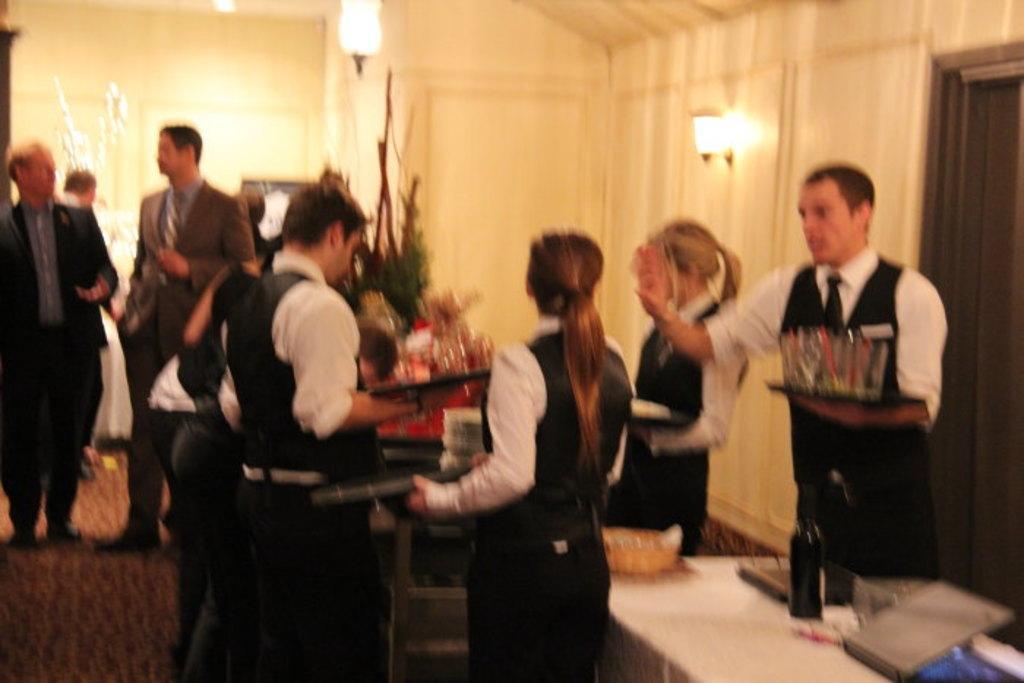Please provide a concise description of this image. In front of the picture, we see the people are standing. In the right bottom, we see a table on which laptop, water bottle, basket and some other objects are placed. In the middle, we see a red table on which some objects are placed. In front of them, we see a stand. Behind the table, we see a plant pot. On the left side, we see two men in the uniform are talking to each other. Behind them, we see two people are standing. Behind them, we see a wall on which the photo frame is placed. On the right side, we see a door, a white wall and the lights. 